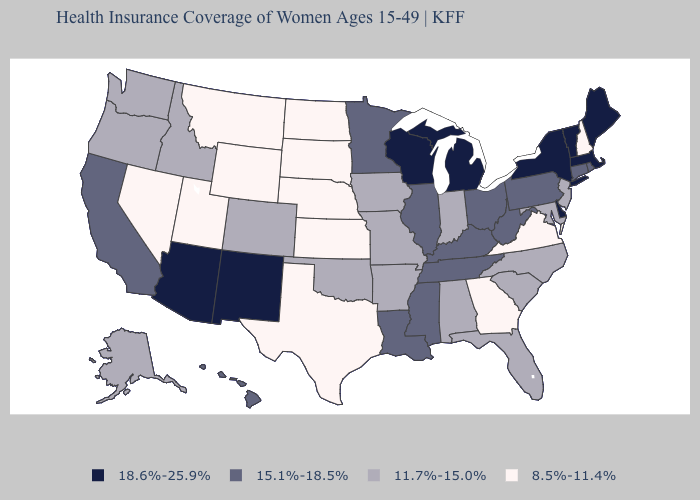Which states have the lowest value in the USA?
Answer briefly. Georgia, Kansas, Montana, Nebraska, Nevada, New Hampshire, North Dakota, South Dakota, Texas, Utah, Virginia, Wyoming. Does Montana have the lowest value in the West?
Short answer required. Yes. Name the states that have a value in the range 8.5%-11.4%?
Concise answer only. Georgia, Kansas, Montana, Nebraska, Nevada, New Hampshire, North Dakota, South Dakota, Texas, Utah, Virginia, Wyoming. Name the states that have a value in the range 18.6%-25.9%?
Quick response, please. Arizona, Delaware, Maine, Massachusetts, Michigan, New Mexico, New York, Vermont, Wisconsin. Does Delaware have the highest value in the South?
Answer briefly. Yes. Name the states that have a value in the range 11.7%-15.0%?
Keep it brief. Alabama, Alaska, Arkansas, Colorado, Florida, Idaho, Indiana, Iowa, Maryland, Missouri, New Jersey, North Carolina, Oklahoma, Oregon, South Carolina, Washington. Name the states that have a value in the range 11.7%-15.0%?
Answer briefly. Alabama, Alaska, Arkansas, Colorado, Florida, Idaho, Indiana, Iowa, Maryland, Missouri, New Jersey, North Carolina, Oklahoma, Oregon, South Carolina, Washington. What is the value of Arizona?
Give a very brief answer. 18.6%-25.9%. What is the lowest value in the MidWest?
Concise answer only. 8.5%-11.4%. Among the states that border Arkansas , which have the lowest value?
Concise answer only. Texas. Name the states that have a value in the range 15.1%-18.5%?
Answer briefly. California, Connecticut, Hawaii, Illinois, Kentucky, Louisiana, Minnesota, Mississippi, Ohio, Pennsylvania, Rhode Island, Tennessee, West Virginia. Does the map have missing data?
Give a very brief answer. No. Does the first symbol in the legend represent the smallest category?
Be succinct. No. What is the value of North Carolina?
Quick response, please. 11.7%-15.0%. What is the highest value in states that border Texas?
Answer briefly. 18.6%-25.9%. 